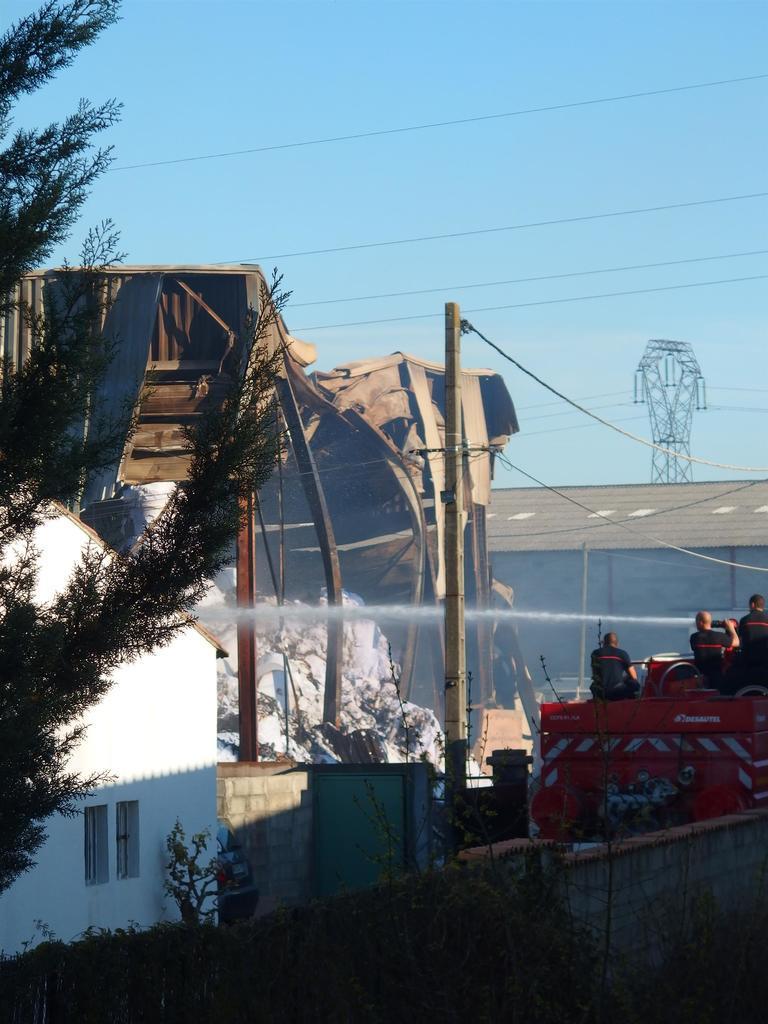Describe this image in one or two sentences. In this picture I can see few plants and a tree in front and in the middle of this picture I see the buildings, a pole, wires, a fire engine on which there are 3 persons and I see the flow of water. In the background I see the sky and a tower on the right side of this image. 